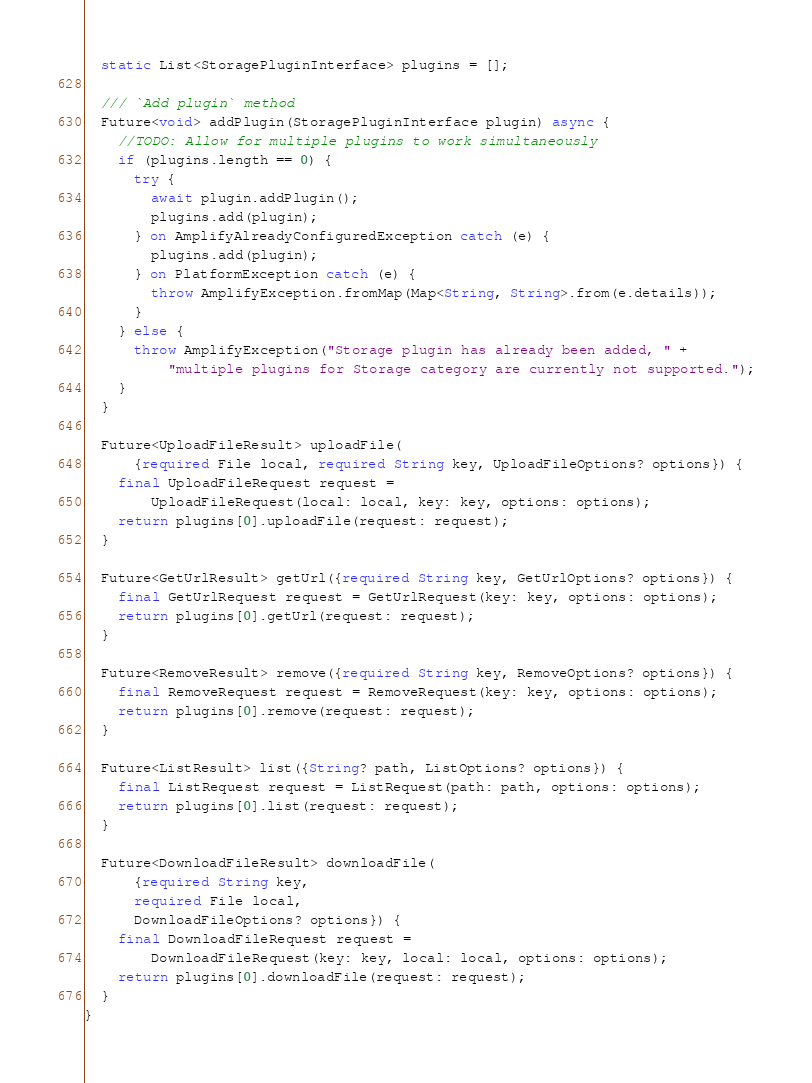Convert code to text. <code><loc_0><loc_0><loc_500><loc_500><_Dart_>  static List<StoragePluginInterface> plugins = [];

  /// `Add plugin` method
  Future<void> addPlugin(StoragePluginInterface plugin) async {
    //TODO: Allow for multiple plugins to work simultaneously
    if (plugins.length == 0) {
      try {
        await plugin.addPlugin();
        plugins.add(plugin);
      } on AmplifyAlreadyConfiguredException catch (e) {
        plugins.add(plugin);
      } on PlatformException catch (e) {
        throw AmplifyException.fromMap(Map<String, String>.from(e.details));
      }
    } else {
      throw AmplifyException("Storage plugin has already been added, " +
          "multiple plugins for Storage category are currently not supported.");
    }
  }

  Future<UploadFileResult> uploadFile(
      {required File local, required String key, UploadFileOptions? options}) {
    final UploadFileRequest request =
        UploadFileRequest(local: local, key: key, options: options);
    return plugins[0].uploadFile(request: request);
  }

  Future<GetUrlResult> getUrl({required String key, GetUrlOptions? options}) {
    final GetUrlRequest request = GetUrlRequest(key: key, options: options);
    return plugins[0].getUrl(request: request);
  }

  Future<RemoveResult> remove({required String key, RemoveOptions? options}) {
    final RemoveRequest request = RemoveRequest(key: key, options: options);
    return plugins[0].remove(request: request);
  }

  Future<ListResult> list({String? path, ListOptions? options}) {
    final ListRequest request = ListRequest(path: path, options: options);
    return plugins[0].list(request: request);
  }

  Future<DownloadFileResult> downloadFile(
      {required String key,
      required File local,
      DownloadFileOptions? options}) {
    final DownloadFileRequest request =
        DownloadFileRequest(key: key, local: local, options: options);
    return plugins[0].downloadFile(request: request);
  }
}
</code> 